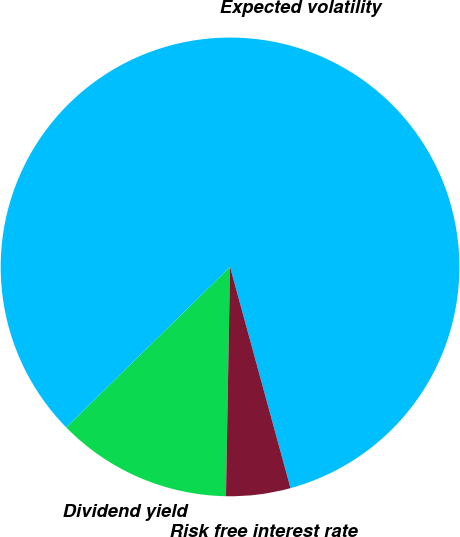<chart> <loc_0><loc_0><loc_500><loc_500><pie_chart><fcel>Dividend yield<fcel>Expected volatility<fcel>Risk free interest rate<nl><fcel>12.38%<fcel>83.09%<fcel>4.53%<nl></chart> 